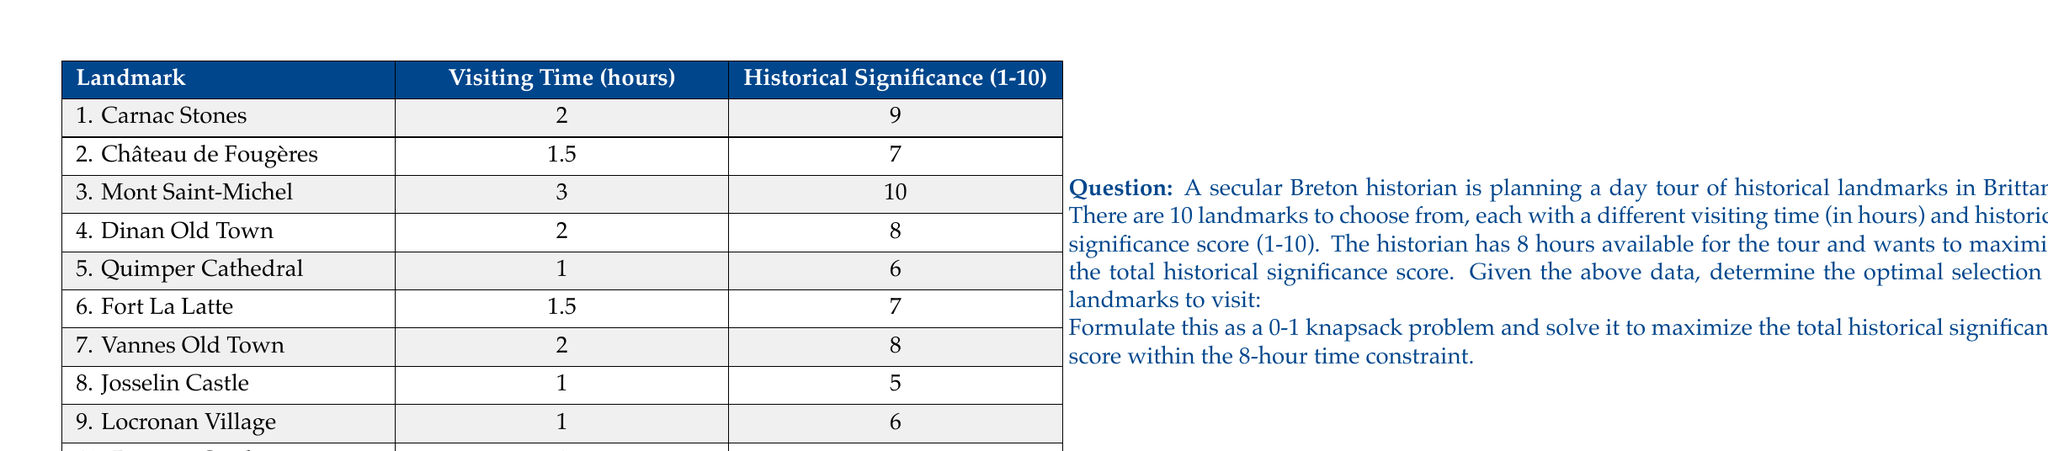Teach me how to tackle this problem. To solve this problem, we'll use the 0-1 knapsack algorithm, which is ideal for optimization problems where we need to select items (in this case, landmarks) with given weights (visiting times) and values (historical significance scores) to maximize the total value while staying within a weight limit (time constraint).

Let's define our variables:
$x_i$ = 1 if landmark i is selected, 0 otherwise
$v_i$ = historical significance score of landmark i
$t_i$ = visiting time of landmark i

Our objective function is to maximize the total historical significance:

$$\text{Maximize } \sum_{i=1}^{10} v_i x_i$$

Subject to the time constraint:

$$\sum_{i=1}^{10} t_i x_i \leq 8$$

We can solve this using dynamic programming. Let's create a table where rows represent landmarks and columns represent time (in half-hour increments up to 8 hours).

The recurrence relation for filling the table is:

$$dp[i][j] = \max(dp[i-1][j], dp[i-1][j-t_i] + v_i)$$

Where $dp[i][j]$ represents the maximum historical significance score achievable using the first i landmarks and j half-hours.

After filling the table, the optimal solution will be in $dp[10][16]$ (as we have 10 landmarks and 16 half-hours).

Here's the filled table (showing only the last few rows for brevity):

```
       0   1   2   3   4   5   6   7   8   9  10  11  12  13  14  15  16
...
8     29  29  29  29  35  35  35  35  37  37  37  37  40  40  40  40  43
9     29  29  29  29  35  35  35  35  37  37  37  37  40  40  40  40  43
10    29  29  29  29  35  35  35  35  37  37  37  37  40  40  40  40  43
```

The maximum score achievable is 43.

To determine which landmarks to visit, we backtrack through the table:

1. Start at $dp[10][16]$ = 43
2. If $dp[i][j] \neq dp[i-1][j]$, include landmark i and move to $dp[i-1][j-t_i]$
3. Otherwise, move to $dp[i-1][j]$

Following this process, we find that the optimal selection includes:
- Carnac Stones (2 hours, score 9)
- Mont Saint-Michel (3 hours, score 10)
- Quimper Cathedral (1 hour, score 6)
- Fort La Latte (1.5 hours, score 7)
- Josselin Castle (1 hour, score 5)

Total time: 7.5 hours
Total historical significance score: 37
Answer: The optimal selection of landmarks to visit within the 8-hour constraint, maximizing the total historical significance score, is:
1. Carnac Stones
2. Mont Saint-Michel
3. Quimper Cathedral
4. Fort La Latte
5. Josselin Castle

This selection results in a total historical significance score of 37 and takes 7.5 hours to visit. 